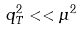<formula> <loc_0><loc_0><loc_500><loc_500>q _ { T } ^ { 2 } < < \mu ^ { 2 }</formula> 